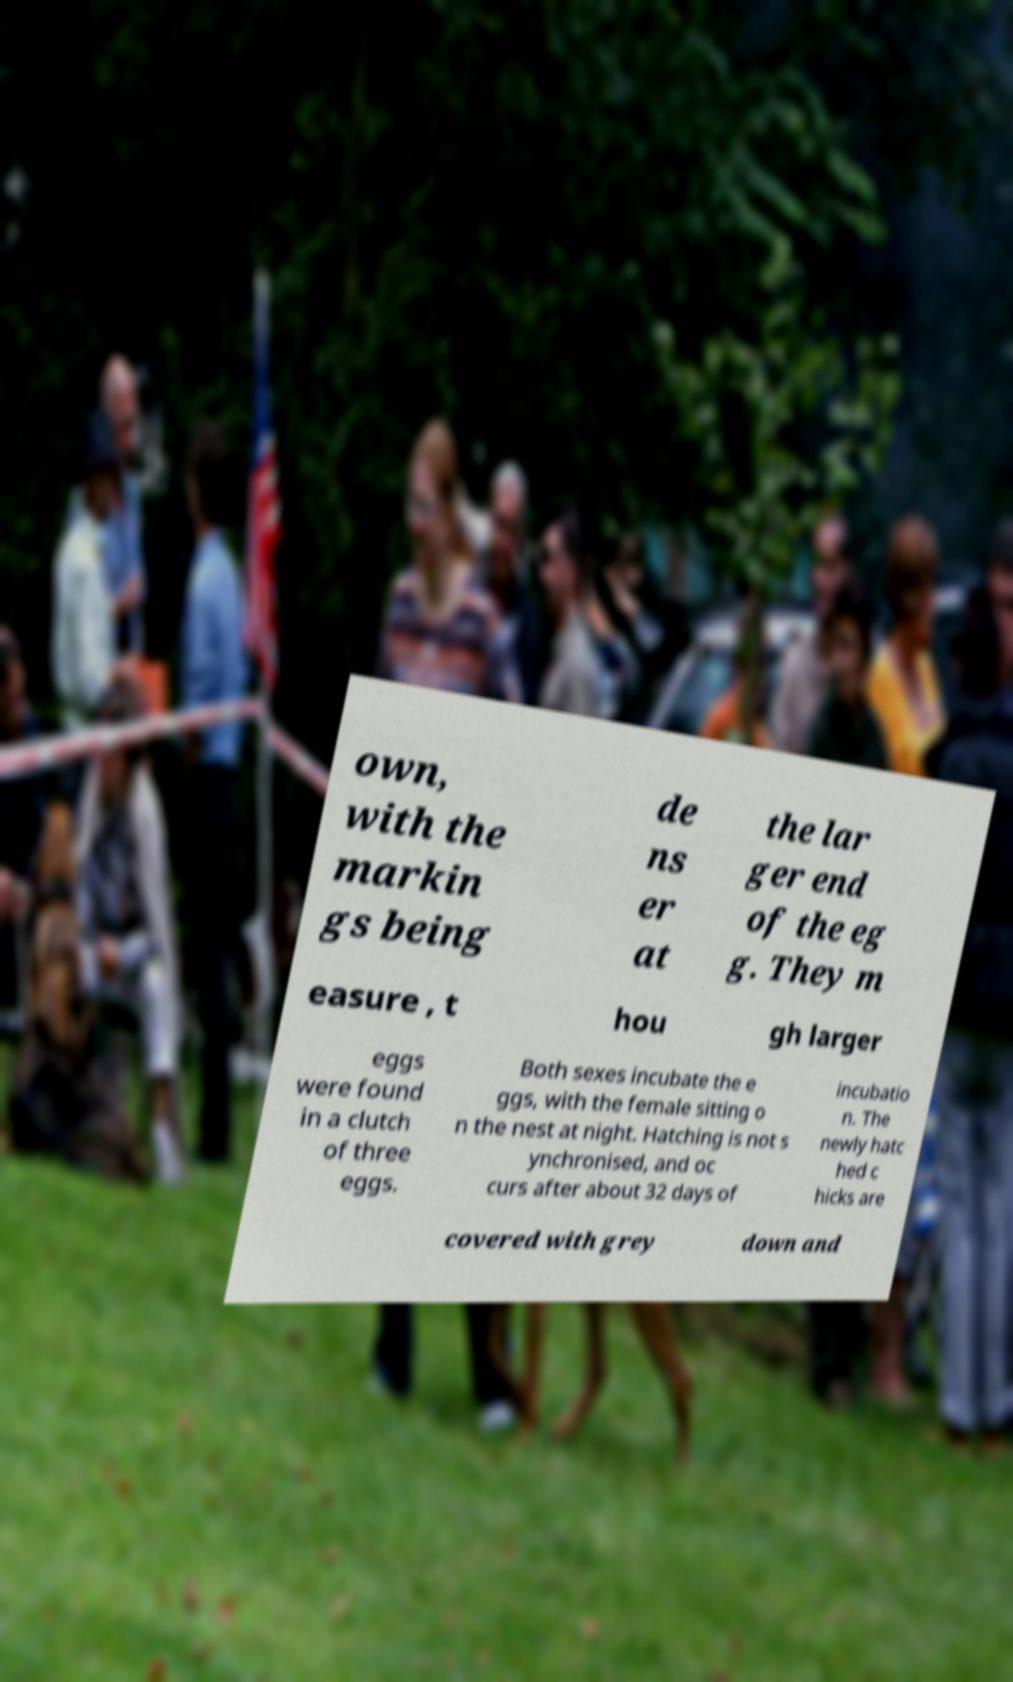For documentation purposes, I need the text within this image transcribed. Could you provide that? own, with the markin gs being de ns er at the lar ger end of the eg g. They m easure , t hou gh larger eggs were found in a clutch of three eggs. Both sexes incubate the e ggs, with the female sitting o n the nest at night. Hatching is not s ynchronised, and oc curs after about 32 days of incubatio n. The newly hatc hed c hicks are covered with grey down and 